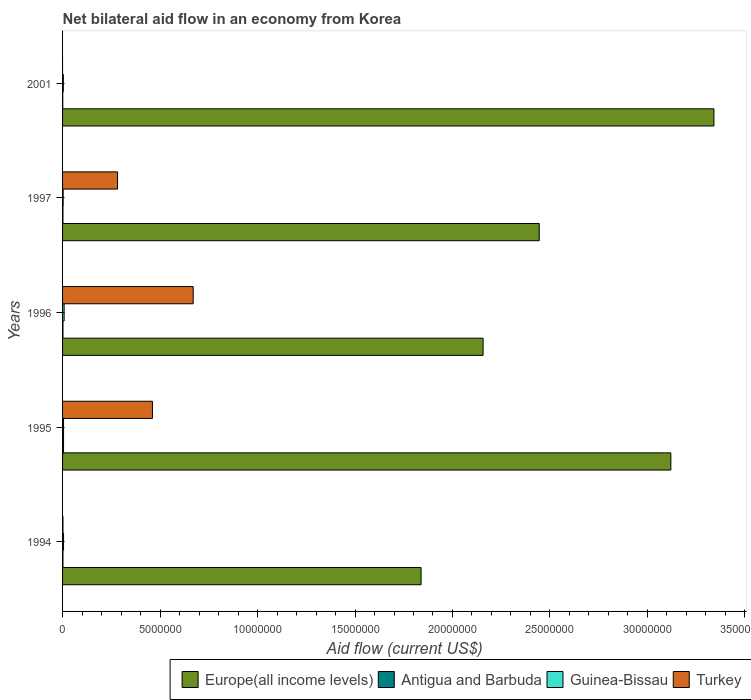Are the number of bars per tick equal to the number of legend labels?
Give a very brief answer. No. Are the number of bars on each tick of the Y-axis equal?
Make the answer very short. No. How many bars are there on the 5th tick from the top?
Offer a very short reply. 4. How many bars are there on the 4th tick from the bottom?
Make the answer very short. 4. What is the net bilateral aid flow in Europe(all income levels) in 1996?
Provide a short and direct response. 2.16e+07. Across all years, what is the maximum net bilateral aid flow in Europe(all income levels)?
Provide a succinct answer. 3.34e+07. Across all years, what is the minimum net bilateral aid flow in Turkey?
Make the answer very short. 0. What is the total net bilateral aid flow in Turkey in the graph?
Make the answer very short. 1.42e+07. What is the difference between the net bilateral aid flow in Turkey in 1996 and the net bilateral aid flow in Europe(all income levels) in 1997?
Keep it short and to the point. -1.78e+07. What is the average net bilateral aid flow in Guinea-Bissau per year?
Keep it short and to the point. 5.00e+04. In the year 1996, what is the difference between the net bilateral aid flow in Antigua and Barbuda and net bilateral aid flow in Turkey?
Provide a succinct answer. -6.68e+06. What is the ratio of the net bilateral aid flow in Europe(all income levels) in 1995 to that in 1996?
Provide a short and direct response. 1.45. Is the net bilateral aid flow in Europe(all income levels) in 1995 less than that in 2001?
Your answer should be compact. Yes. What is the difference between the highest and the second highest net bilateral aid flow in Europe(all income levels)?
Provide a succinct answer. 2.21e+06. What is the difference between the highest and the lowest net bilateral aid flow in Europe(all income levels)?
Your answer should be compact. 1.50e+07. In how many years, is the net bilateral aid flow in Turkey greater than the average net bilateral aid flow in Turkey taken over all years?
Keep it short and to the point. 2. Are all the bars in the graph horizontal?
Provide a short and direct response. Yes. How many years are there in the graph?
Provide a succinct answer. 5. Are the values on the major ticks of X-axis written in scientific E-notation?
Your answer should be very brief. No. Does the graph contain any zero values?
Provide a short and direct response. Yes. Does the graph contain grids?
Ensure brevity in your answer.  No. Where does the legend appear in the graph?
Make the answer very short. Bottom right. How are the legend labels stacked?
Keep it short and to the point. Horizontal. What is the title of the graph?
Provide a short and direct response. Net bilateral aid flow in an economy from Korea. Does "Benin" appear as one of the legend labels in the graph?
Give a very brief answer. No. What is the label or title of the X-axis?
Offer a very short reply. Aid flow (current US$). What is the Aid flow (current US$) of Europe(all income levels) in 1994?
Give a very brief answer. 1.84e+07. What is the Aid flow (current US$) in Europe(all income levels) in 1995?
Ensure brevity in your answer.  3.12e+07. What is the Aid flow (current US$) of Turkey in 1995?
Offer a very short reply. 4.61e+06. What is the Aid flow (current US$) of Europe(all income levels) in 1996?
Give a very brief answer. 2.16e+07. What is the Aid flow (current US$) in Guinea-Bissau in 1996?
Offer a very short reply. 8.00e+04. What is the Aid flow (current US$) of Turkey in 1996?
Offer a very short reply. 6.70e+06. What is the Aid flow (current US$) of Europe(all income levels) in 1997?
Give a very brief answer. 2.44e+07. What is the Aid flow (current US$) of Guinea-Bissau in 1997?
Provide a short and direct response. 3.00e+04. What is the Aid flow (current US$) in Turkey in 1997?
Offer a very short reply. 2.82e+06. What is the Aid flow (current US$) of Europe(all income levels) in 2001?
Offer a terse response. 3.34e+07. What is the Aid flow (current US$) in Antigua and Barbuda in 2001?
Make the answer very short. 10000. What is the Aid flow (current US$) of Guinea-Bissau in 2001?
Offer a terse response. 4.00e+04. Across all years, what is the maximum Aid flow (current US$) in Europe(all income levels)?
Keep it short and to the point. 3.34e+07. Across all years, what is the maximum Aid flow (current US$) of Turkey?
Offer a very short reply. 6.70e+06. Across all years, what is the minimum Aid flow (current US$) in Europe(all income levels)?
Ensure brevity in your answer.  1.84e+07. Across all years, what is the minimum Aid flow (current US$) of Antigua and Barbuda?
Make the answer very short. 10000. Across all years, what is the minimum Aid flow (current US$) in Guinea-Bissau?
Provide a short and direct response. 3.00e+04. Across all years, what is the minimum Aid flow (current US$) in Turkey?
Offer a very short reply. 0. What is the total Aid flow (current US$) in Europe(all income levels) in the graph?
Ensure brevity in your answer.  1.29e+08. What is the total Aid flow (current US$) in Antigua and Barbuda in the graph?
Offer a terse response. 1.20e+05. What is the total Aid flow (current US$) in Guinea-Bissau in the graph?
Make the answer very short. 2.50e+05. What is the total Aid flow (current US$) in Turkey in the graph?
Offer a very short reply. 1.42e+07. What is the difference between the Aid flow (current US$) of Europe(all income levels) in 1994 and that in 1995?
Your response must be concise. -1.28e+07. What is the difference between the Aid flow (current US$) of Antigua and Barbuda in 1994 and that in 1995?
Offer a very short reply. -3.00e+04. What is the difference between the Aid flow (current US$) in Guinea-Bissau in 1994 and that in 1995?
Make the answer very short. 0. What is the difference between the Aid flow (current US$) of Turkey in 1994 and that in 1995?
Your answer should be compact. -4.59e+06. What is the difference between the Aid flow (current US$) in Europe(all income levels) in 1994 and that in 1996?
Your response must be concise. -3.18e+06. What is the difference between the Aid flow (current US$) of Guinea-Bissau in 1994 and that in 1996?
Offer a terse response. -3.00e+04. What is the difference between the Aid flow (current US$) in Turkey in 1994 and that in 1996?
Give a very brief answer. -6.68e+06. What is the difference between the Aid flow (current US$) in Europe(all income levels) in 1994 and that in 1997?
Your response must be concise. -6.06e+06. What is the difference between the Aid flow (current US$) in Antigua and Barbuda in 1994 and that in 1997?
Provide a short and direct response. 0. What is the difference between the Aid flow (current US$) in Guinea-Bissau in 1994 and that in 1997?
Ensure brevity in your answer.  2.00e+04. What is the difference between the Aid flow (current US$) in Turkey in 1994 and that in 1997?
Offer a terse response. -2.80e+06. What is the difference between the Aid flow (current US$) in Europe(all income levels) in 1994 and that in 2001?
Offer a terse response. -1.50e+07. What is the difference between the Aid flow (current US$) in Antigua and Barbuda in 1994 and that in 2001?
Give a very brief answer. 10000. What is the difference between the Aid flow (current US$) of Europe(all income levels) in 1995 and that in 1996?
Make the answer very short. 9.63e+06. What is the difference between the Aid flow (current US$) of Antigua and Barbuda in 1995 and that in 1996?
Offer a very short reply. 3.00e+04. What is the difference between the Aid flow (current US$) of Turkey in 1995 and that in 1996?
Provide a short and direct response. -2.09e+06. What is the difference between the Aid flow (current US$) of Europe(all income levels) in 1995 and that in 1997?
Keep it short and to the point. 6.75e+06. What is the difference between the Aid flow (current US$) in Turkey in 1995 and that in 1997?
Give a very brief answer. 1.79e+06. What is the difference between the Aid flow (current US$) in Europe(all income levels) in 1995 and that in 2001?
Make the answer very short. -2.21e+06. What is the difference between the Aid flow (current US$) in Antigua and Barbuda in 1995 and that in 2001?
Offer a very short reply. 4.00e+04. What is the difference between the Aid flow (current US$) of Guinea-Bissau in 1995 and that in 2001?
Make the answer very short. 10000. What is the difference between the Aid flow (current US$) in Europe(all income levels) in 1996 and that in 1997?
Provide a succinct answer. -2.88e+06. What is the difference between the Aid flow (current US$) in Guinea-Bissau in 1996 and that in 1997?
Offer a very short reply. 5.00e+04. What is the difference between the Aid flow (current US$) of Turkey in 1996 and that in 1997?
Keep it short and to the point. 3.88e+06. What is the difference between the Aid flow (current US$) of Europe(all income levels) in 1996 and that in 2001?
Ensure brevity in your answer.  -1.18e+07. What is the difference between the Aid flow (current US$) in Antigua and Barbuda in 1996 and that in 2001?
Your answer should be very brief. 10000. What is the difference between the Aid flow (current US$) in Europe(all income levels) in 1997 and that in 2001?
Offer a terse response. -8.96e+06. What is the difference between the Aid flow (current US$) of Antigua and Barbuda in 1997 and that in 2001?
Your response must be concise. 10000. What is the difference between the Aid flow (current US$) of Europe(all income levels) in 1994 and the Aid flow (current US$) of Antigua and Barbuda in 1995?
Offer a very short reply. 1.83e+07. What is the difference between the Aid flow (current US$) of Europe(all income levels) in 1994 and the Aid flow (current US$) of Guinea-Bissau in 1995?
Ensure brevity in your answer.  1.83e+07. What is the difference between the Aid flow (current US$) in Europe(all income levels) in 1994 and the Aid flow (current US$) in Turkey in 1995?
Offer a terse response. 1.38e+07. What is the difference between the Aid flow (current US$) of Antigua and Barbuda in 1994 and the Aid flow (current US$) of Turkey in 1995?
Provide a short and direct response. -4.59e+06. What is the difference between the Aid flow (current US$) in Guinea-Bissau in 1994 and the Aid flow (current US$) in Turkey in 1995?
Offer a terse response. -4.56e+06. What is the difference between the Aid flow (current US$) of Europe(all income levels) in 1994 and the Aid flow (current US$) of Antigua and Barbuda in 1996?
Give a very brief answer. 1.84e+07. What is the difference between the Aid flow (current US$) in Europe(all income levels) in 1994 and the Aid flow (current US$) in Guinea-Bissau in 1996?
Provide a short and direct response. 1.83e+07. What is the difference between the Aid flow (current US$) of Europe(all income levels) in 1994 and the Aid flow (current US$) of Turkey in 1996?
Provide a short and direct response. 1.17e+07. What is the difference between the Aid flow (current US$) of Antigua and Barbuda in 1994 and the Aid flow (current US$) of Guinea-Bissau in 1996?
Offer a very short reply. -6.00e+04. What is the difference between the Aid flow (current US$) in Antigua and Barbuda in 1994 and the Aid flow (current US$) in Turkey in 1996?
Offer a very short reply. -6.68e+06. What is the difference between the Aid flow (current US$) in Guinea-Bissau in 1994 and the Aid flow (current US$) in Turkey in 1996?
Offer a terse response. -6.65e+06. What is the difference between the Aid flow (current US$) of Europe(all income levels) in 1994 and the Aid flow (current US$) of Antigua and Barbuda in 1997?
Ensure brevity in your answer.  1.84e+07. What is the difference between the Aid flow (current US$) of Europe(all income levels) in 1994 and the Aid flow (current US$) of Guinea-Bissau in 1997?
Your answer should be compact. 1.84e+07. What is the difference between the Aid flow (current US$) in Europe(all income levels) in 1994 and the Aid flow (current US$) in Turkey in 1997?
Your answer should be compact. 1.56e+07. What is the difference between the Aid flow (current US$) in Antigua and Barbuda in 1994 and the Aid flow (current US$) in Turkey in 1997?
Make the answer very short. -2.80e+06. What is the difference between the Aid flow (current US$) of Guinea-Bissau in 1994 and the Aid flow (current US$) of Turkey in 1997?
Provide a short and direct response. -2.77e+06. What is the difference between the Aid flow (current US$) of Europe(all income levels) in 1994 and the Aid flow (current US$) of Antigua and Barbuda in 2001?
Give a very brief answer. 1.84e+07. What is the difference between the Aid flow (current US$) of Europe(all income levels) in 1994 and the Aid flow (current US$) of Guinea-Bissau in 2001?
Provide a succinct answer. 1.84e+07. What is the difference between the Aid flow (current US$) of Europe(all income levels) in 1995 and the Aid flow (current US$) of Antigua and Barbuda in 1996?
Your response must be concise. 3.12e+07. What is the difference between the Aid flow (current US$) of Europe(all income levels) in 1995 and the Aid flow (current US$) of Guinea-Bissau in 1996?
Your response must be concise. 3.11e+07. What is the difference between the Aid flow (current US$) of Europe(all income levels) in 1995 and the Aid flow (current US$) of Turkey in 1996?
Your answer should be compact. 2.45e+07. What is the difference between the Aid flow (current US$) of Antigua and Barbuda in 1995 and the Aid flow (current US$) of Guinea-Bissau in 1996?
Ensure brevity in your answer.  -3.00e+04. What is the difference between the Aid flow (current US$) in Antigua and Barbuda in 1995 and the Aid flow (current US$) in Turkey in 1996?
Provide a succinct answer. -6.65e+06. What is the difference between the Aid flow (current US$) in Guinea-Bissau in 1995 and the Aid flow (current US$) in Turkey in 1996?
Provide a succinct answer. -6.65e+06. What is the difference between the Aid flow (current US$) in Europe(all income levels) in 1995 and the Aid flow (current US$) in Antigua and Barbuda in 1997?
Provide a succinct answer. 3.12e+07. What is the difference between the Aid flow (current US$) in Europe(all income levels) in 1995 and the Aid flow (current US$) in Guinea-Bissau in 1997?
Your answer should be very brief. 3.12e+07. What is the difference between the Aid flow (current US$) in Europe(all income levels) in 1995 and the Aid flow (current US$) in Turkey in 1997?
Offer a terse response. 2.84e+07. What is the difference between the Aid flow (current US$) in Antigua and Barbuda in 1995 and the Aid flow (current US$) in Turkey in 1997?
Keep it short and to the point. -2.77e+06. What is the difference between the Aid flow (current US$) of Guinea-Bissau in 1995 and the Aid flow (current US$) of Turkey in 1997?
Ensure brevity in your answer.  -2.77e+06. What is the difference between the Aid flow (current US$) in Europe(all income levels) in 1995 and the Aid flow (current US$) in Antigua and Barbuda in 2001?
Provide a short and direct response. 3.12e+07. What is the difference between the Aid flow (current US$) in Europe(all income levels) in 1995 and the Aid flow (current US$) in Guinea-Bissau in 2001?
Keep it short and to the point. 3.12e+07. What is the difference between the Aid flow (current US$) of Europe(all income levels) in 1996 and the Aid flow (current US$) of Antigua and Barbuda in 1997?
Your answer should be compact. 2.16e+07. What is the difference between the Aid flow (current US$) of Europe(all income levels) in 1996 and the Aid flow (current US$) of Guinea-Bissau in 1997?
Ensure brevity in your answer.  2.15e+07. What is the difference between the Aid flow (current US$) of Europe(all income levels) in 1996 and the Aid flow (current US$) of Turkey in 1997?
Provide a short and direct response. 1.88e+07. What is the difference between the Aid flow (current US$) in Antigua and Barbuda in 1996 and the Aid flow (current US$) in Turkey in 1997?
Keep it short and to the point. -2.80e+06. What is the difference between the Aid flow (current US$) in Guinea-Bissau in 1996 and the Aid flow (current US$) in Turkey in 1997?
Your answer should be very brief. -2.74e+06. What is the difference between the Aid flow (current US$) in Europe(all income levels) in 1996 and the Aid flow (current US$) in Antigua and Barbuda in 2001?
Ensure brevity in your answer.  2.16e+07. What is the difference between the Aid flow (current US$) in Europe(all income levels) in 1996 and the Aid flow (current US$) in Guinea-Bissau in 2001?
Offer a very short reply. 2.15e+07. What is the difference between the Aid flow (current US$) of Europe(all income levels) in 1997 and the Aid flow (current US$) of Antigua and Barbuda in 2001?
Give a very brief answer. 2.44e+07. What is the difference between the Aid flow (current US$) of Europe(all income levels) in 1997 and the Aid flow (current US$) of Guinea-Bissau in 2001?
Provide a short and direct response. 2.44e+07. What is the average Aid flow (current US$) of Europe(all income levels) per year?
Give a very brief answer. 2.58e+07. What is the average Aid flow (current US$) in Antigua and Barbuda per year?
Your answer should be very brief. 2.40e+04. What is the average Aid flow (current US$) in Guinea-Bissau per year?
Your answer should be compact. 5.00e+04. What is the average Aid flow (current US$) of Turkey per year?
Provide a short and direct response. 2.83e+06. In the year 1994, what is the difference between the Aid flow (current US$) of Europe(all income levels) and Aid flow (current US$) of Antigua and Barbuda?
Ensure brevity in your answer.  1.84e+07. In the year 1994, what is the difference between the Aid flow (current US$) in Europe(all income levels) and Aid flow (current US$) in Guinea-Bissau?
Offer a very short reply. 1.83e+07. In the year 1994, what is the difference between the Aid flow (current US$) in Europe(all income levels) and Aid flow (current US$) in Turkey?
Your answer should be compact. 1.84e+07. In the year 1994, what is the difference between the Aid flow (current US$) in Antigua and Barbuda and Aid flow (current US$) in Guinea-Bissau?
Provide a short and direct response. -3.00e+04. In the year 1995, what is the difference between the Aid flow (current US$) of Europe(all income levels) and Aid flow (current US$) of Antigua and Barbuda?
Provide a succinct answer. 3.12e+07. In the year 1995, what is the difference between the Aid flow (current US$) of Europe(all income levels) and Aid flow (current US$) of Guinea-Bissau?
Offer a very short reply. 3.12e+07. In the year 1995, what is the difference between the Aid flow (current US$) of Europe(all income levels) and Aid flow (current US$) of Turkey?
Keep it short and to the point. 2.66e+07. In the year 1995, what is the difference between the Aid flow (current US$) in Antigua and Barbuda and Aid flow (current US$) in Turkey?
Your response must be concise. -4.56e+06. In the year 1995, what is the difference between the Aid flow (current US$) in Guinea-Bissau and Aid flow (current US$) in Turkey?
Provide a short and direct response. -4.56e+06. In the year 1996, what is the difference between the Aid flow (current US$) of Europe(all income levels) and Aid flow (current US$) of Antigua and Barbuda?
Your answer should be very brief. 2.16e+07. In the year 1996, what is the difference between the Aid flow (current US$) of Europe(all income levels) and Aid flow (current US$) of Guinea-Bissau?
Your answer should be compact. 2.15e+07. In the year 1996, what is the difference between the Aid flow (current US$) in Europe(all income levels) and Aid flow (current US$) in Turkey?
Ensure brevity in your answer.  1.49e+07. In the year 1996, what is the difference between the Aid flow (current US$) of Antigua and Barbuda and Aid flow (current US$) of Guinea-Bissau?
Your answer should be very brief. -6.00e+04. In the year 1996, what is the difference between the Aid flow (current US$) in Antigua and Barbuda and Aid flow (current US$) in Turkey?
Provide a succinct answer. -6.68e+06. In the year 1996, what is the difference between the Aid flow (current US$) of Guinea-Bissau and Aid flow (current US$) of Turkey?
Provide a short and direct response. -6.62e+06. In the year 1997, what is the difference between the Aid flow (current US$) in Europe(all income levels) and Aid flow (current US$) in Antigua and Barbuda?
Your answer should be very brief. 2.44e+07. In the year 1997, what is the difference between the Aid flow (current US$) in Europe(all income levels) and Aid flow (current US$) in Guinea-Bissau?
Offer a terse response. 2.44e+07. In the year 1997, what is the difference between the Aid flow (current US$) of Europe(all income levels) and Aid flow (current US$) of Turkey?
Make the answer very short. 2.16e+07. In the year 1997, what is the difference between the Aid flow (current US$) of Antigua and Barbuda and Aid flow (current US$) of Guinea-Bissau?
Provide a succinct answer. -10000. In the year 1997, what is the difference between the Aid flow (current US$) in Antigua and Barbuda and Aid flow (current US$) in Turkey?
Give a very brief answer. -2.80e+06. In the year 1997, what is the difference between the Aid flow (current US$) of Guinea-Bissau and Aid flow (current US$) of Turkey?
Your response must be concise. -2.79e+06. In the year 2001, what is the difference between the Aid flow (current US$) in Europe(all income levels) and Aid flow (current US$) in Antigua and Barbuda?
Give a very brief answer. 3.34e+07. In the year 2001, what is the difference between the Aid flow (current US$) in Europe(all income levels) and Aid flow (current US$) in Guinea-Bissau?
Make the answer very short. 3.34e+07. In the year 2001, what is the difference between the Aid flow (current US$) of Antigua and Barbuda and Aid flow (current US$) of Guinea-Bissau?
Your response must be concise. -3.00e+04. What is the ratio of the Aid flow (current US$) of Europe(all income levels) in 1994 to that in 1995?
Offer a terse response. 0.59. What is the ratio of the Aid flow (current US$) of Antigua and Barbuda in 1994 to that in 1995?
Give a very brief answer. 0.4. What is the ratio of the Aid flow (current US$) of Guinea-Bissau in 1994 to that in 1995?
Provide a succinct answer. 1. What is the ratio of the Aid flow (current US$) in Turkey in 1994 to that in 1995?
Ensure brevity in your answer.  0. What is the ratio of the Aid flow (current US$) of Europe(all income levels) in 1994 to that in 1996?
Provide a short and direct response. 0.85. What is the ratio of the Aid flow (current US$) of Turkey in 1994 to that in 1996?
Offer a very short reply. 0. What is the ratio of the Aid flow (current US$) of Europe(all income levels) in 1994 to that in 1997?
Your answer should be very brief. 0.75. What is the ratio of the Aid flow (current US$) of Guinea-Bissau in 1994 to that in 1997?
Give a very brief answer. 1.67. What is the ratio of the Aid flow (current US$) in Turkey in 1994 to that in 1997?
Provide a short and direct response. 0.01. What is the ratio of the Aid flow (current US$) in Europe(all income levels) in 1994 to that in 2001?
Your answer should be very brief. 0.55. What is the ratio of the Aid flow (current US$) in Europe(all income levels) in 1995 to that in 1996?
Ensure brevity in your answer.  1.45. What is the ratio of the Aid flow (current US$) of Antigua and Barbuda in 1995 to that in 1996?
Make the answer very short. 2.5. What is the ratio of the Aid flow (current US$) of Turkey in 1995 to that in 1996?
Offer a terse response. 0.69. What is the ratio of the Aid flow (current US$) of Europe(all income levels) in 1995 to that in 1997?
Offer a very short reply. 1.28. What is the ratio of the Aid flow (current US$) in Antigua and Barbuda in 1995 to that in 1997?
Give a very brief answer. 2.5. What is the ratio of the Aid flow (current US$) of Guinea-Bissau in 1995 to that in 1997?
Provide a succinct answer. 1.67. What is the ratio of the Aid flow (current US$) in Turkey in 1995 to that in 1997?
Your answer should be very brief. 1.63. What is the ratio of the Aid flow (current US$) in Europe(all income levels) in 1995 to that in 2001?
Provide a succinct answer. 0.93. What is the ratio of the Aid flow (current US$) of Guinea-Bissau in 1995 to that in 2001?
Your response must be concise. 1.25. What is the ratio of the Aid flow (current US$) in Europe(all income levels) in 1996 to that in 1997?
Provide a succinct answer. 0.88. What is the ratio of the Aid flow (current US$) of Guinea-Bissau in 1996 to that in 1997?
Provide a short and direct response. 2.67. What is the ratio of the Aid flow (current US$) of Turkey in 1996 to that in 1997?
Ensure brevity in your answer.  2.38. What is the ratio of the Aid flow (current US$) in Europe(all income levels) in 1996 to that in 2001?
Your answer should be compact. 0.65. What is the ratio of the Aid flow (current US$) in Guinea-Bissau in 1996 to that in 2001?
Keep it short and to the point. 2. What is the ratio of the Aid flow (current US$) of Europe(all income levels) in 1997 to that in 2001?
Give a very brief answer. 0.73. What is the ratio of the Aid flow (current US$) in Antigua and Barbuda in 1997 to that in 2001?
Keep it short and to the point. 2. What is the difference between the highest and the second highest Aid flow (current US$) of Europe(all income levels)?
Give a very brief answer. 2.21e+06. What is the difference between the highest and the second highest Aid flow (current US$) of Guinea-Bissau?
Your answer should be compact. 3.00e+04. What is the difference between the highest and the second highest Aid flow (current US$) in Turkey?
Make the answer very short. 2.09e+06. What is the difference between the highest and the lowest Aid flow (current US$) of Europe(all income levels)?
Ensure brevity in your answer.  1.50e+07. What is the difference between the highest and the lowest Aid flow (current US$) of Guinea-Bissau?
Your response must be concise. 5.00e+04. What is the difference between the highest and the lowest Aid flow (current US$) of Turkey?
Provide a short and direct response. 6.70e+06. 